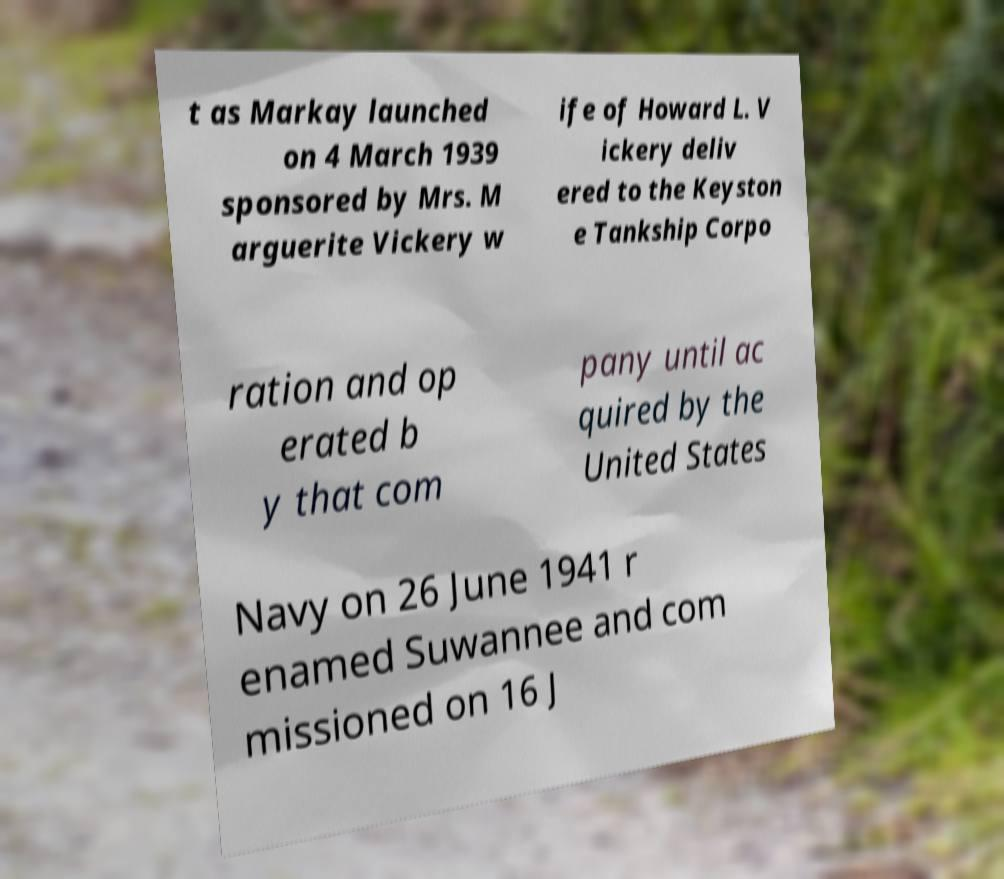Can you read and provide the text displayed in the image?This photo seems to have some interesting text. Can you extract and type it out for me? t as Markay launched on 4 March 1939 sponsored by Mrs. M arguerite Vickery w ife of Howard L. V ickery deliv ered to the Keyston e Tankship Corpo ration and op erated b y that com pany until ac quired by the United States Navy on 26 June 1941 r enamed Suwannee and com missioned on 16 J 